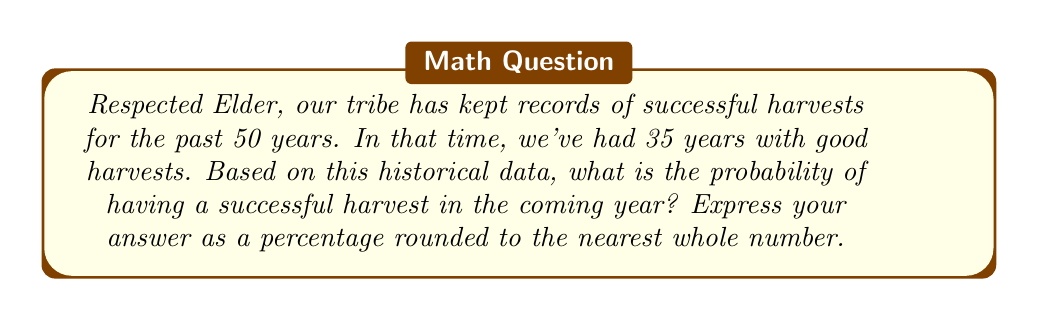Can you answer this question? To calculate the probability of a successful harvest based on historical data, we can use the concept of relative frequency as an estimate of probability. Here's how we can approach this problem:

1. Identify the total number of years in our data set:
   $n = 50$ years

2. Count the number of successful harvests:
   $s = 35$ successful years

3. Calculate the probability using the formula:
   $$P(\text{successful harvest}) = \frac{\text{number of successful harvests}}{\text{total number of years}}$$

4. Plug in our values:
   $$P(\text{successful harvest}) = \frac{35}{50}$$

5. Perform the division:
   $$P(\text{successful harvest}) = 0.7$$

6. Convert to a percentage:
   $$0.7 \times 100\% = 70\%$$

7. Round to the nearest whole number:
   The result is already a whole number, so it remains 70%.

Therefore, based on our historical data, there is a 70% chance of having a successful harvest in the coming year.
Answer: 70% 